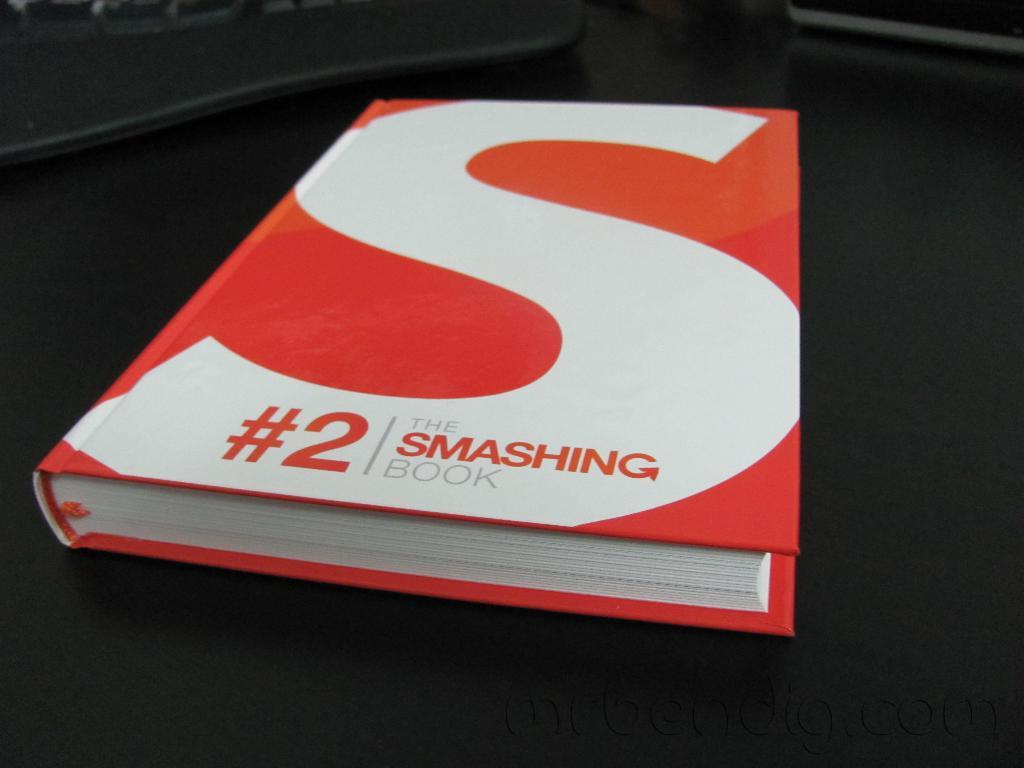<image>
Create a compact narrative representing the image presented. A red and white book titled" #2 The Smashing Book." 